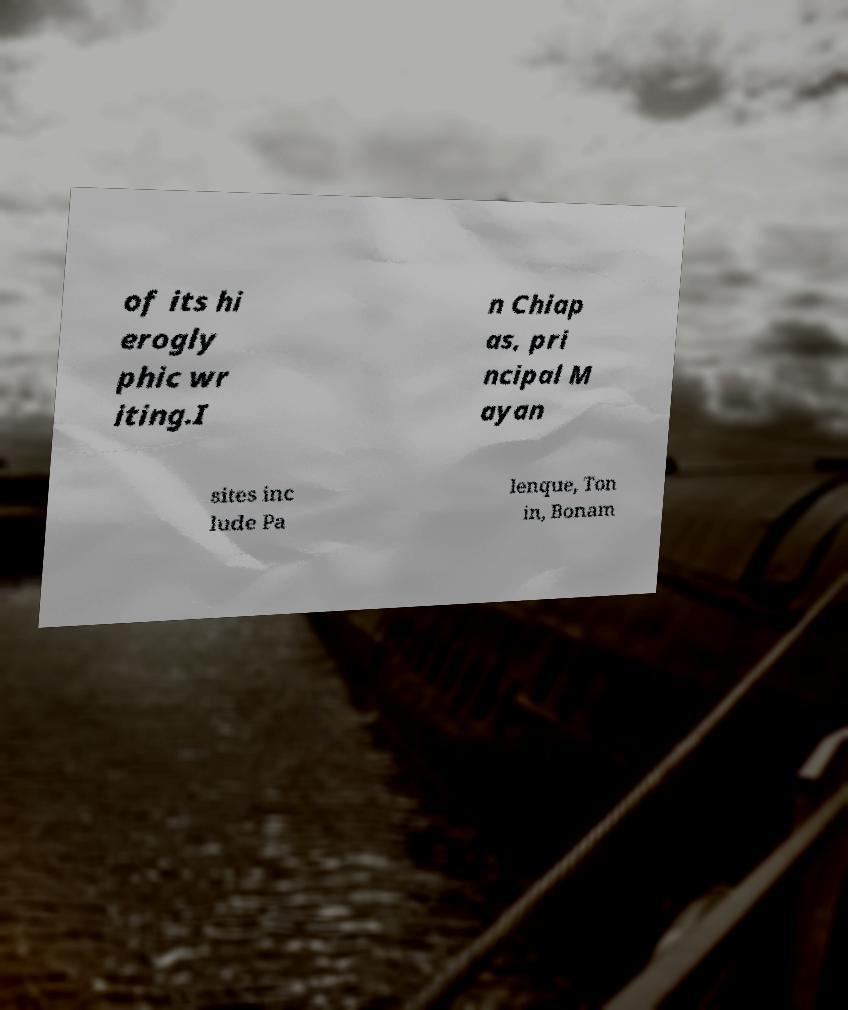There's text embedded in this image that I need extracted. Can you transcribe it verbatim? of its hi erogly phic wr iting.I n Chiap as, pri ncipal M ayan sites inc lude Pa lenque, Ton in, Bonam 